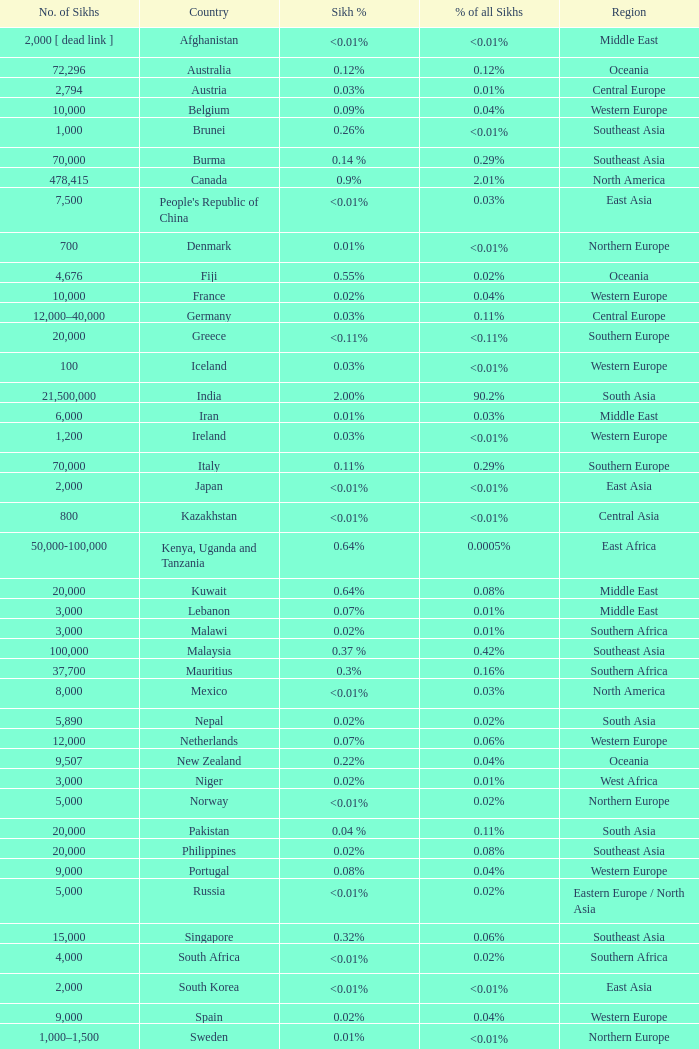What is the number of sikhs in Japan? 2000.0. 